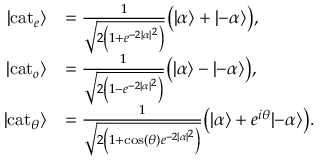<formula> <loc_0><loc_0><loc_500><loc_500>{ \begin{array} { r l } { | c a t _ { e } \rangle } & { = { \frac { 1 } { \sqrt { 2 \left ( 1 + e ^ { - 2 | \alpha | ^ { 2 } } \right ) } } } { \left ( } | \alpha \rangle + | { - } \alpha \rangle { \right ) } , } \\ { | c a t _ { o } \rangle } & { = { \frac { 1 } { \sqrt { 2 \left ( 1 - e ^ { - 2 | \alpha | ^ { 2 } } \right ) } } } { \left ( } | \alpha \rangle - | { - } \alpha \rangle { \right ) } , } \\ { | c a t _ { \theta } \rangle } & { = { \frac { 1 } { \sqrt { 2 \left ( 1 + \cos ( \theta ) e ^ { - 2 | \alpha | ^ { 2 } } \right ) } } } { \left ( } | \alpha \rangle + e ^ { i \theta } | { - } \alpha \rangle { \right ) } . } \end{array} }</formula> 